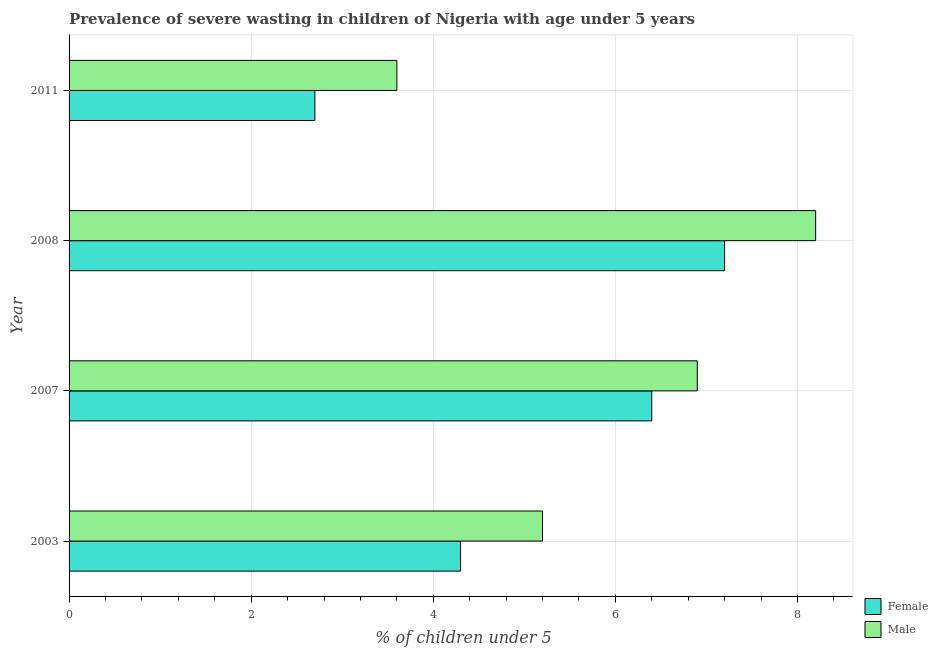How many groups of bars are there?
Your answer should be compact. 4. Are the number of bars per tick equal to the number of legend labels?
Ensure brevity in your answer.  Yes. Are the number of bars on each tick of the Y-axis equal?
Ensure brevity in your answer.  Yes. How many bars are there on the 2nd tick from the top?
Offer a terse response. 2. In how many cases, is the number of bars for a given year not equal to the number of legend labels?
Offer a very short reply. 0. What is the percentage of undernourished female children in 2003?
Give a very brief answer. 4.3. Across all years, what is the maximum percentage of undernourished female children?
Your answer should be very brief. 7.2. Across all years, what is the minimum percentage of undernourished female children?
Your answer should be very brief. 2.7. In which year was the percentage of undernourished female children minimum?
Give a very brief answer. 2011. What is the total percentage of undernourished male children in the graph?
Keep it short and to the point. 23.9. What is the difference between the percentage of undernourished male children in 2003 and that in 2007?
Offer a very short reply. -1.7. What is the difference between the percentage of undernourished male children in 2003 and the percentage of undernourished female children in 2007?
Offer a terse response. -1.2. What is the average percentage of undernourished female children per year?
Make the answer very short. 5.15. In the year 2007, what is the difference between the percentage of undernourished female children and percentage of undernourished male children?
Your response must be concise. -0.5. In how many years, is the percentage of undernourished female children greater than 6 %?
Provide a succinct answer. 2. What is the ratio of the percentage of undernourished female children in 2003 to that in 2008?
Make the answer very short. 0.6. Is the percentage of undernourished male children in 2003 less than that in 2007?
Provide a short and direct response. Yes. Is the difference between the percentage of undernourished male children in 2008 and 2011 greater than the difference between the percentage of undernourished female children in 2008 and 2011?
Give a very brief answer. Yes. What is the difference between the highest and the lowest percentage of undernourished female children?
Offer a very short reply. 4.5. In how many years, is the percentage of undernourished female children greater than the average percentage of undernourished female children taken over all years?
Provide a short and direct response. 2. What does the 1st bar from the bottom in 2003 represents?
Provide a succinct answer. Female. Are all the bars in the graph horizontal?
Ensure brevity in your answer.  Yes. What is the difference between two consecutive major ticks on the X-axis?
Offer a terse response. 2. Are the values on the major ticks of X-axis written in scientific E-notation?
Offer a terse response. No. Does the graph contain any zero values?
Offer a terse response. No. Does the graph contain grids?
Your response must be concise. Yes. Where does the legend appear in the graph?
Ensure brevity in your answer.  Bottom right. How many legend labels are there?
Your answer should be compact. 2. How are the legend labels stacked?
Your answer should be very brief. Vertical. What is the title of the graph?
Keep it short and to the point. Prevalence of severe wasting in children of Nigeria with age under 5 years. Does "Time to import" appear as one of the legend labels in the graph?
Provide a succinct answer. No. What is the label or title of the X-axis?
Make the answer very short.  % of children under 5. What is the  % of children under 5 of Female in 2003?
Give a very brief answer. 4.3. What is the  % of children under 5 in Male in 2003?
Your answer should be compact. 5.2. What is the  % of children under 5 in Female in 2007?
Offer a very short reply. 6.4. What is the  % of children under 5 in Male in 2007?
Offer a terse response. 6.9. What is the  % of children under 5 in Female in 2008?
Provide a succinct answer. 7.2. What is the  % of children under 5 of Male in 2008?
Ensure brevity in your answer.  8.2. What is the  % of children under 5 of Female in 2011?
Keep it short and to the point. 2.7. What is the  % of children under 5 of Male in 2011?
Your answer should be very brief. 3.6. Across all years, what is the maximum  % of children under 5 in Female?
Ensure brevity in your answer.  7.2. Across all years, what is the maximum  % of children under 5 in Male?
Your answer should be compact. 8.2. Across all years, what is the minimum  % of children under 5 in Female?
Make the answer very short. 2.7. Across all years, what is the minimum  % of children under 5 of Male?
Offer a very short reply. 3.6. What is the total  % of children under 5 of Female in the graph?
Your answer should be very brief. 20.6. What is the total  % of children under 5 of Male in the graph?
Offer a terse response. 23.9. What is the difference between the  % of children under 5 of Female in 2003 and that in 2008?
Give a very brief answer. -2.9. What is the difference between the  % of children under 5 of Male in 2003 and that in 2008?
Your answer should be compact. -3. What is the difference between the  % of children under 5 of Female in 2003 and that in 2011?
Provide a short and direct response. 1.6. What is the difference between the  % of children under 5 of Female in 2007 and that in 2011?
Your answer should be very brief. 3.7. What is the difference between the  % of children under 5 of Male in 2007 and that in 2011?
Make the answer very short. 3.3. What is the difference between the  % of children under 5 in Male in 2008 and that in 2011?
Offer a very short reply. 4.6. What is the difference between the  % of children under 5 of Female in 2003 and the  % of children under 5 of Male in 2007?
Your response must be concise. -2.6. What is the difference between the  % of children under 5 in Female in 2003 and the  % of children under 5 in Male in 2008?
Offer a terse response. -3.9. What is the difference between the  % of children under 5 of Female in 2003 and the  % of children under 5 of Male in 2011?
Provide a short and direct response. 0.7. What is the difference between the  % of children under 5 of Female in 2007 and the  % of children under 5 of Male in 2008?
Provide a short and direct response. -1.8. What is the difference between the  % of children under 5 in Female in 2008 and the  % of children under 5 in Male in 2011?
Your response must be concise. 3.6. What is the average  % of children under 5 in Female per year?
Keep it short and to the point. 5.15. What is the average  % of children under 5 of Male per year?
Keep it short and to the point. 5.97. In the year 2007, what is the difference between the  % of children under 5 of Female and  % of children under 5 of Male?
Ensure brevity in your answer.  -0.5. In the year 2011, what is the difference between the  % of children under 5 of Female and  % of children under 5 of Male?
Provide a short and direct response. -0.9. What is the ratio of the  % of children under 5 of Female in 2003 to that in 2007?
Give a very brief answer. 0.67. What is the ratio of the  % of children under 5 in Male in 2003 to that in 2007?
Offer a very short reply. 0.75. What is the ratio of the  % of children under 5 in Female in 2003 to that in 2008?
Your answer should be compact. 0.6. What is the ratio of the  % of children under 5 in Male in 2003 to that in 2008?
Offer a very short reply. 0.63. What is the ratio of the  % of children under 5 in Female in 2003 to that in 2011?
Give a very brief answer. 1.59. What is the ratio of the  % of children under 5 of Male in 2003 to that in 2011?
Provide a short and direct response. 1.44. What is the ratio of the  % of children under 5 in Male in 2007 to that in 2008?
Your answer should be compact. 0.84. What is the ratio of the  % of children under 5 in Female in 2007 to that in 2011?
Make the answer very short. 2.37. What is the ratio of the  % of children under 5 of Male in 2007 to that in 2011?
Your response must be concise. 1.92. What is the ratio of the  % of children under 5 of Female in 2008 to that in 2011?
Give a very brief answer. 2.67. What is the ratio of the  % of children under 5 in Male in 2008 to that in 2011?
Ensure brevity in your answer.  2.28. What is the difference between the highest and the second highest  % of children under 5 of Female?
Ensure brevity in your answer.  0.8. What is the difference between the highest and the second highest  % of children under 5 in Male?
Your response must be concise. 1.3. What is the difference between the highest and the lowest  % of children under 5 in Female?
Provide a short and direct response. 4.5. 